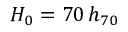<formula> <loc_0><loc_0><loc_500><loc_500>H _ { 0 } = 7 0 \, h _ { 7 0 }</formula> 